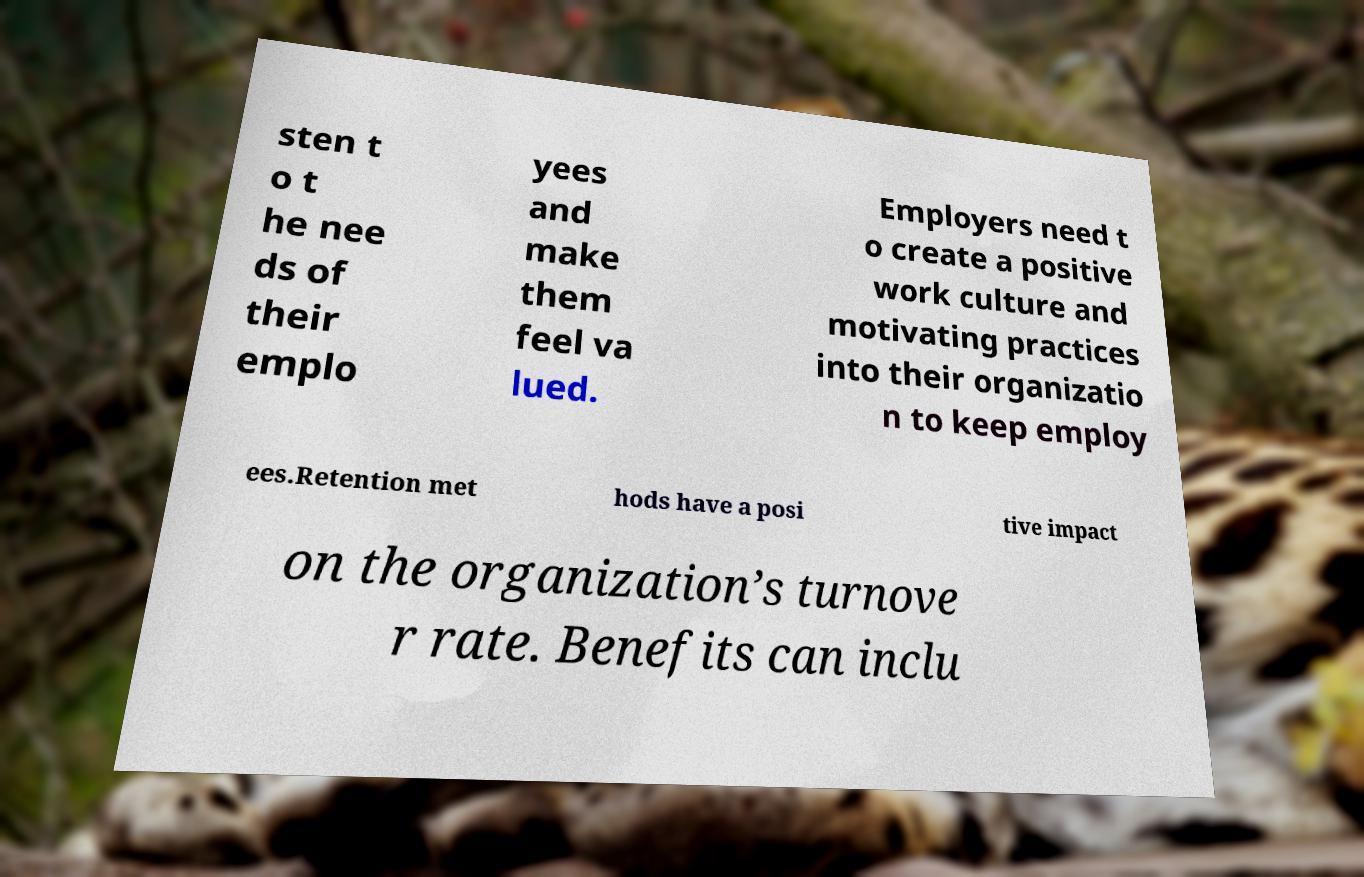There's text embedded in this image that I need extracted. Can you transcribe it verbatim? sten t o t he nee ds of their emplo yees and make them feel va lued. Employers need t o create a positive work culture and motivating practices into their organizatio n to keep employ ees.Retention met hods have a posi tive impact on the organization’s turnove r rate. Benefits can inclu 